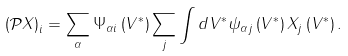<formula> <loc_0><loc_0><loc_500><loc_500>\left ( \mathcal { P } X \right ) _ { i } = \sum _ { \alpha } \Psi _ { \alpha i } \left ( V ^ { \ast } \right ) \sum _ { j } \int d V ^ { * } \psi _ { \alpha j } \left ( V ^ { \ast } \right ) X _ { j } \left ( V ^ { \ast } \right ) .</formula> 